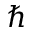<formula> <loc_0><loc_0><loc_500><loc_500>\hbar</formula> 